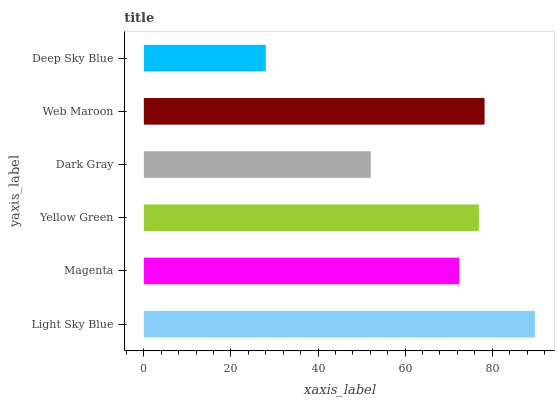Is Deep Sky Blue the minimum?
Answer yes or no. Yes. Is Light Sky Blue the maximum?
Answer yes or no. Yes. Is Magenta the minimum?
Answer yes or no. No. Is Magenta the maximum?
Answer yes or no. No. Is Light Sky Blue greater than Magenta?
Answer yes or no. Yes. Is Magenta less than Light Sky Blue?
Answer yes or no. Yes. Is Magenta greater than Light Sky Blue?
Answer yes or no. No. Is Light Sky Blue less than Magenta?
Answer yes or no. No. Is Yellow Green the high median?
Answer yes or no. Yes. Is Magenta the low median?
Answer yes or no. Yes. Is Deep Sky Blue the high median?
Answer yes or no. No. Is Deep Sky Blue the low median?
Answer yes or no. No. 